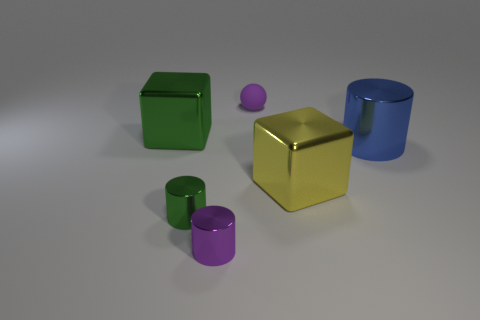Add 4 tiny brown things. How many objects exist? 10 Subtract all blocks. How many objects are left? 4 Add 3 purple shiny cylinders. How many purple shiny cylinders exist? 4 Subtract 0 gray spheres. How many objects are left? 6 Subtract all purple metal cylinders. Subtract all green cylinders. How many objects are left? 4 Add 3 large metal things. How many large metal things are left? 6 